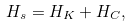Convert formula to latex. <formula><loc_0><loc_0><loc_500><loc_500>H _ { s } = H _ { K } + H _ { C } ,</formula> 